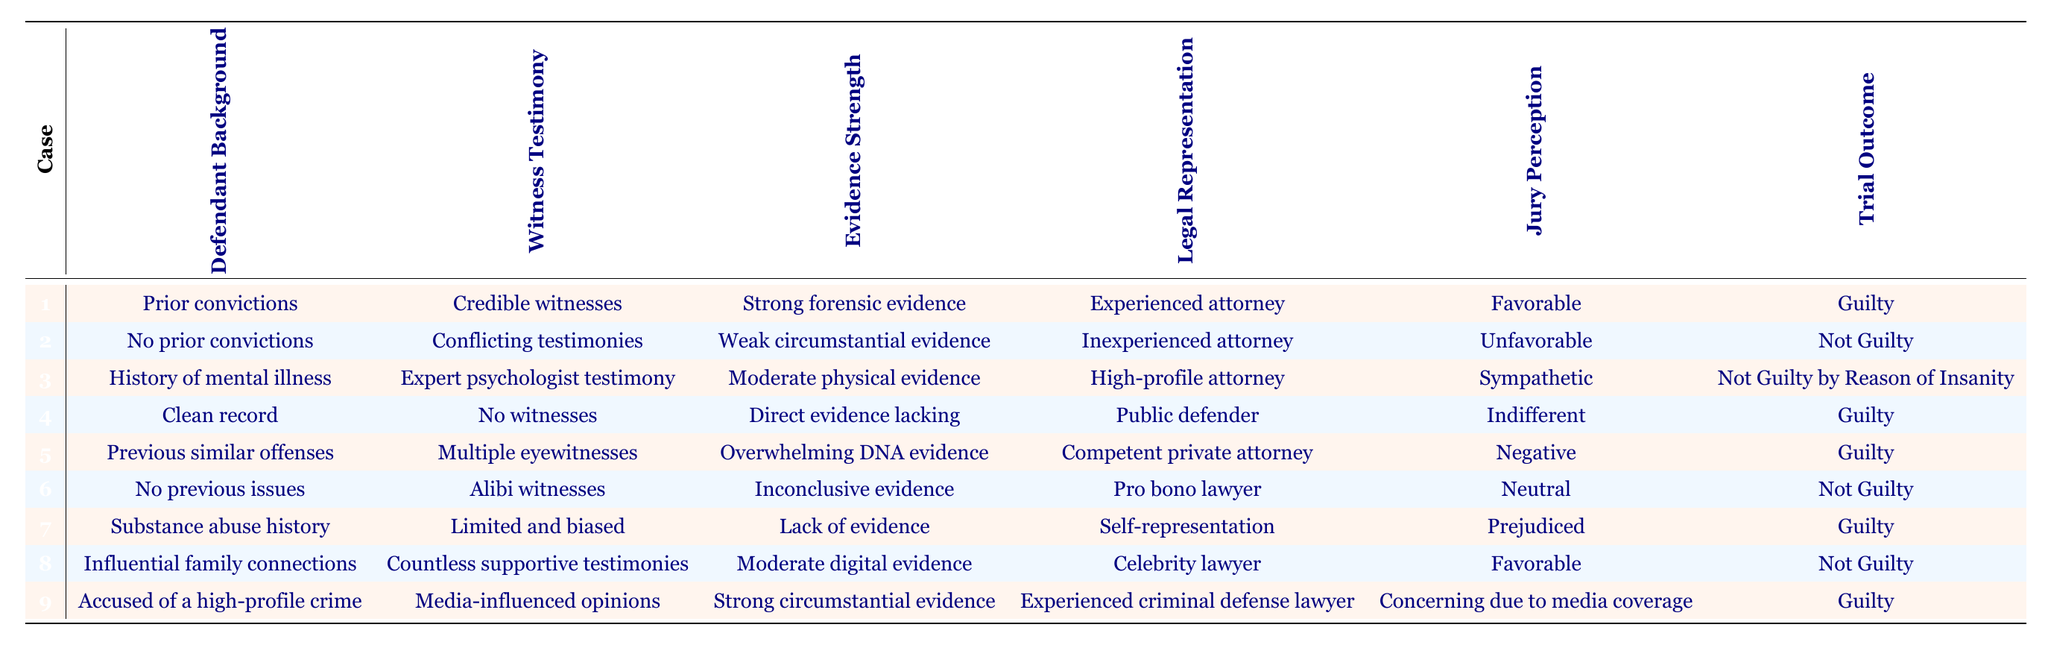What was the trial outcome for a defendant with prior convictions represented by an experienced attorney? In the table, one entry has "Prior convictions" under Defendant Background, and "Experienced attorney" under Legal Representation. The corresponding Trial Outcome for this entry is "Guilty."
Answer: Guilty How many cases resulted in a "Not Guilty" verdict? There are three cases in the table where the Trial Outcome is "Not Guilty": one for a defendant with no prior convictions, one for a defendant with a history of mental illness, and one for a defendant with no previous issues. Hence, the count is 3.
Answer: 3 Is it true that a defendant with a clean record ended up guilty? Looking at the table, there is an entry with "Clean record" as the Defendant Background and "Guilty" as the Trial Outcome. Therefore, this statement is true.
Answer: Yes What is the most common witness testimony among all the cases? The witness testimonies are: "Credible witnesses," "Conflicting testimonies," "Expert psychologist testimony," "No witnesses," "Multiple eyewitnesses," "Alibi witnesses," "Limited and biased," "Countless supportive testimonies," and "Media-influenced opinions". Each testimony appears only once, making it impossible to determine a single common testimony.
Answer: None For how many cases was the jury perception described as unfavorable? In the table, only one case indicates an "Unfavorable" jury perception, which is associated with a defendant who has no prior convictions. Therefore, there is just one such case.
Answer: 1 What is the average strength of evidence for cases resulting in a guilty verdict? For guilty verdicts, the strength of evidence entries are "Strong forensic evidence," "Direct evidence lacking," "Overwhelming DNA evidence," and "Strong circumstantial evidence." Since there are 4 cases, we can assign values (for the purpose of this average): strong=3, moderate=2, and weak=1. Thus, obtaining an average: (3 + 1 + 3 + 2) / 4 = 2.25.
Answer: 2.25 Which defendant background had the highest perceived jury bias? The row with "Substance abuse history" has "Prejudiced" as the jury perception, which suggests a significant bias. Comparing with other jury perceptions which are either neutral or sympathetic, this one stands out most negatively.
Answer: Substance abuse history How many defendants were represented by an inexperienced attorney and were found not guilty? From the table, one defendant with "No prior convictions" and "Inexperienced attorney" was found "Not Guilty." Thus, only one fits this criteria.
Answer: 1 Did having influential family connections influence the trial outcome? The entry about a defendant with "Influential family connections" resulted in a verdict of "Not Guilty," indicating that these connections positively influenced the outcome.
Answer: Yes 